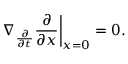Convert formula to latex. <formula><loc_0><loc_0><loc_500><loc_500>\nabla _ { \frac { \partial } { \partial t } } { \frac { \partial } { \partial x } } \right | _ { x = 0 } = 0 .</formula> 